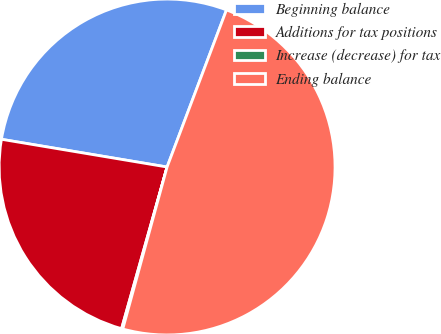Convert chart to OTSL. <chart><loc_0><loc_0><loc_500><loc_500><pie_chart><fcel>Beginning balance<fcel>Additions for tax positions<fcel>Increase (decrease) for tax<fcel>Ending balance<nl><fcel>28.11%<fcel>23.27%<fcel>0.12%<fcel>48.49%<nl></chart> 